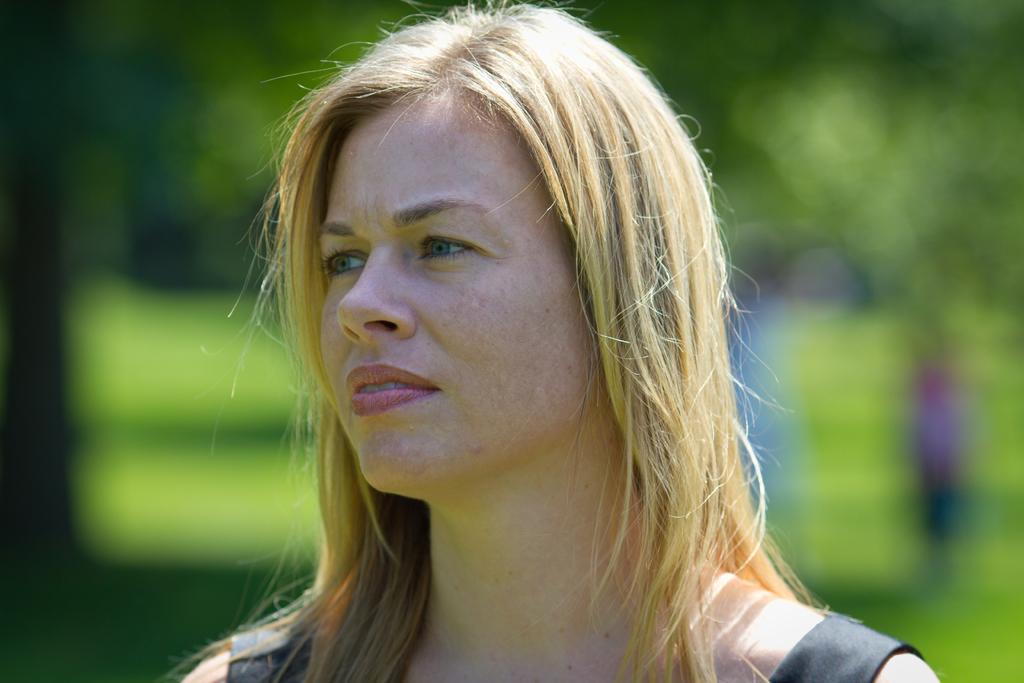How would you summarize this image in a sentence or two? In this picture I can see a woman and I can see blurry background. 